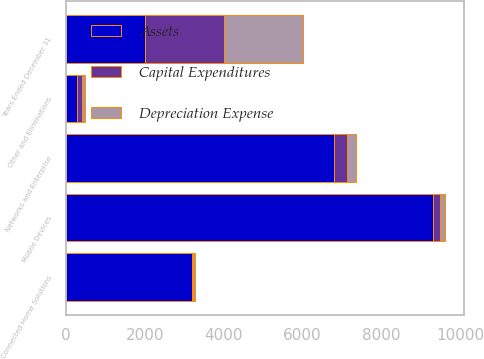<chart> <loc_0><loc_0><loc_500><loc_500><stacked_bar_chart><ecel><fcel>Years Ended December 31<fcel>Mobile Devices<fcel>Networks and Enterprise<fcel>Connected Home Solutions<fcel>Other and Eliminations<nl><fcel>Assets<fcel>2006<fcel>9316<fcel>6812<fcel>3202<fcel>267.5<nl><fcel>Capital Expenditures<fcel>2006<fcel>164<fcel>320<fcel>19<fcel>146<nl><fcel>Depreciation Expense<fcel>2006<fcel>133<fcel>215<fcel>42<fcel>73<nl></chart> 